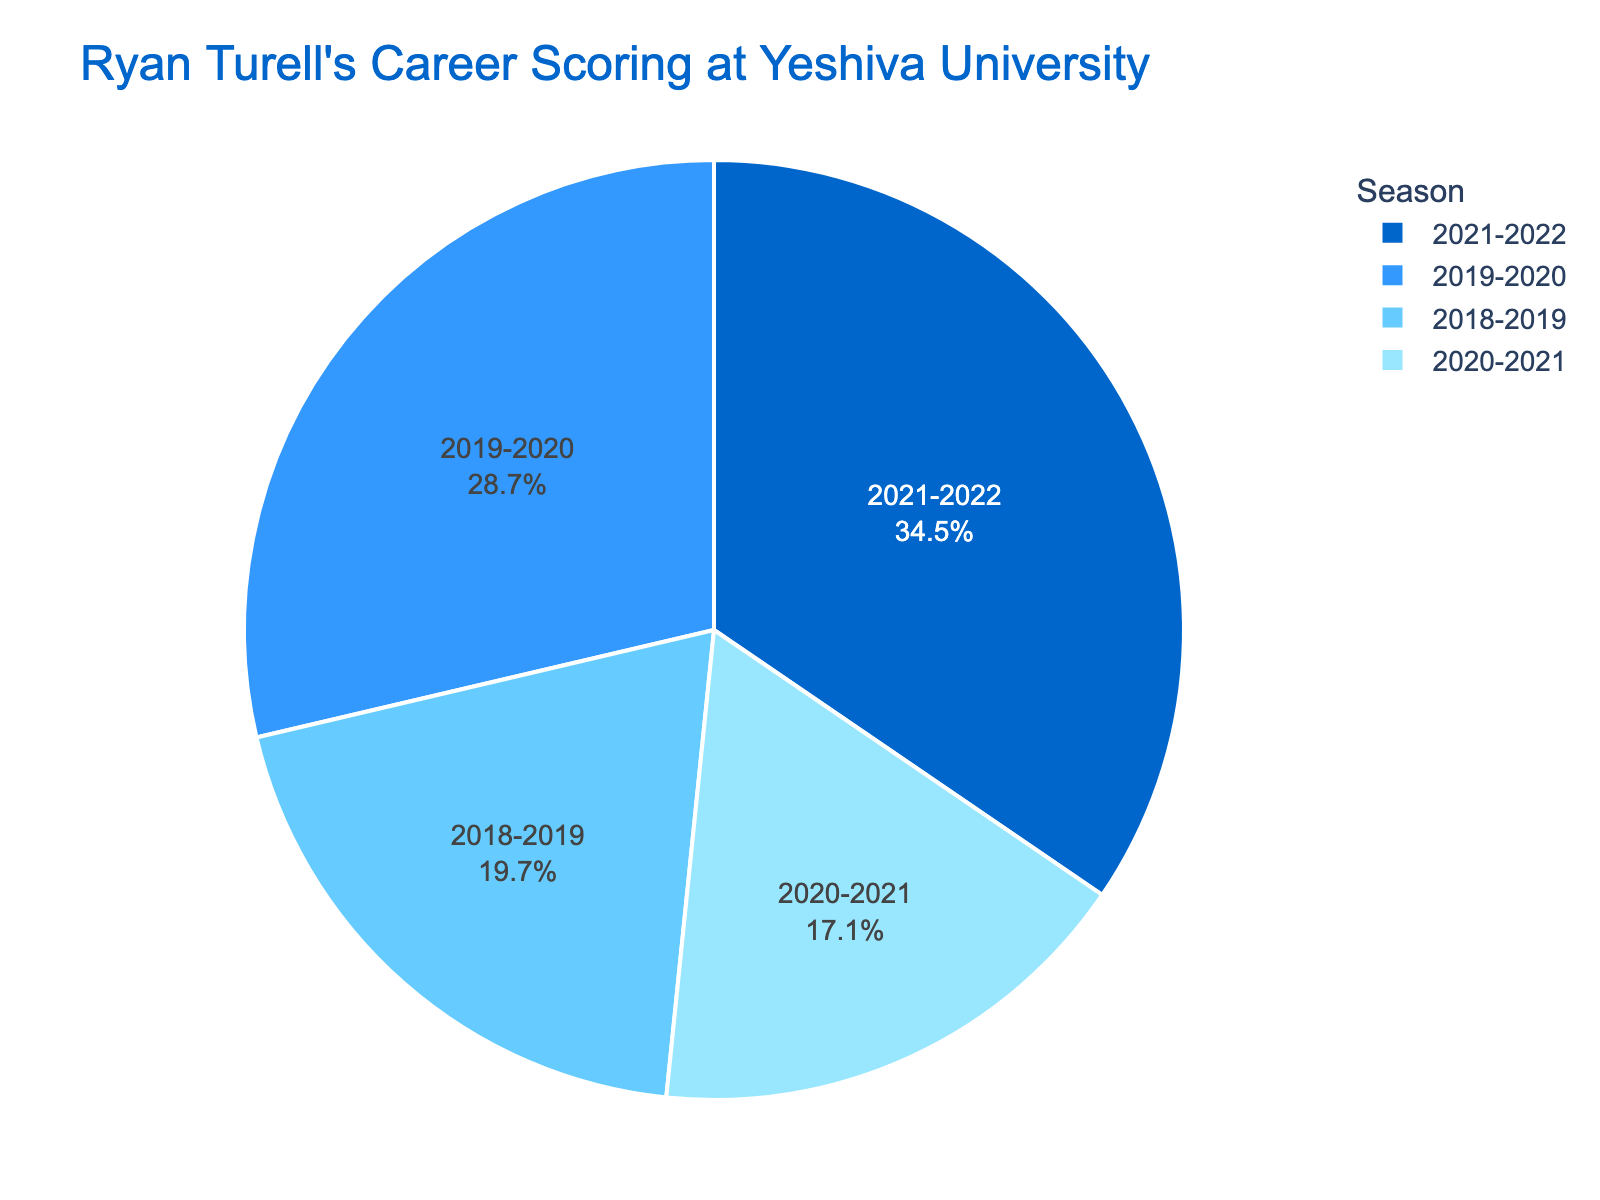What percentage of total points did Ryan Turell score in the 2021-2022 season? Ryan Turell scored 778 points in the 2021-2022 season, and the total points scored over all seasons are (444 + 646 + 385 + 778 = 2253). The percentage is calculated as (778/2253) * 100 ≈ 34.5%.
Answer: 34.5% Which season had the highest scoring for Ryan Turell? By examining the pie chart, the largest segment represents the 2021-2022 season where he scored 778 points, which is the highest among the seasons listed.
Answer: 2021-2022 What's the average number of points Ryan Turell scored per season? The total points scored over all seasons are 444 + 646 + 385 + 778 = 2253. There are 4 seasons, so the average is 2253 / 4 = 563.25.
Answer: 563.25 How many more points did Ryan Turell score in the season with the highest points compared to the season with the lowest points? The highest points scored were in the 2021-2022 season (778 points), and the lowest were in the 2020-2021 season (385 points). The difference is 778 - 385 = 393 points.
Answer: 393 points Arrange the seasons in order from the least to most points scored by Ryan Turell. By examining the pie chart, we arrange the seasons based on the smallest to largest segments: 2020-2021 (385 points), 2018-2019 (444 points), 2019-2020 (646 points), 2021-2022 (778 points).
Answer: 2020-2021, 2018-2019, 2019-2020, 2021-2022 What is the combined percentage of points scored in the 2019-2020 and 2020-2021 seasons? The points scored in 2019-2020 are 646, and in 2020-2021 are 385. Combined, they are 646 + 385 = 1031 points. The total points scored over all seasons is 2253, so the percentage is (1031/2253) * 100 ≈ 45.8%.
Answer: 45.8% If the 2018-2019 and 2020-2021 seasons are considered together, what fraction of the total points did Ryan score in these two seasons? The points scored in 2018-2019 are 444, and in 2020-2021 are 385. Combined, they are 444 + 385 = 829 points. The total points scored over all seasons is 2253, so the fraction is 829 / 2253 ≈ 0.368 or 368/1000.
Answer: 368/1000 Which season contributes the second largest segment in the pie chart? By examining the pie chart, the second largest segment corresponds to the 2019-2020 season where he scored 646 points.
Answer: 2019-2020 What is the total number of points scored by Ryan Turell in the two seasons with the highest scores? The two highest scoring seasons are 2021-2022 (778 points) and 2019-2020 (646 points). Their total is 778 + 646 = 1424 points.
Answer: 1424 points 